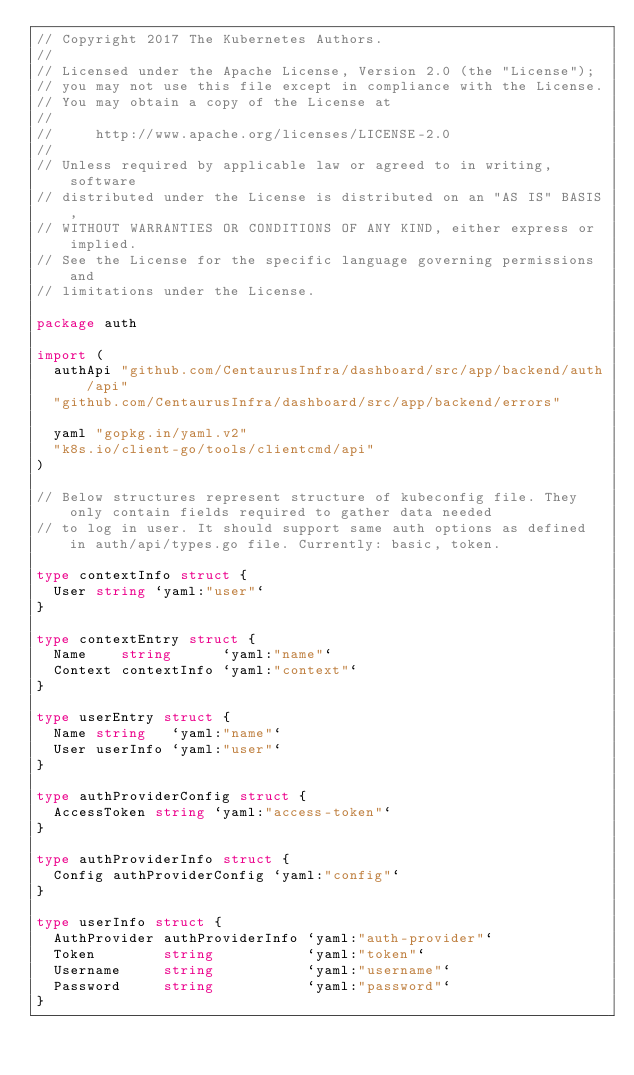<code> <loc_0><loc_0><loc_500><loc_500><_Go_>// Copyright 2017 The Kubernetes Authors.
//
// Licensed under the Apache License, Version 2.0 (the "License");
// you may not use this file except in compliance with the License.
// You may obtain a copy of the License at
//
//     http://www.apache.org/licenses/LICENSE-2.0
//
// Unless required by applicable law or agreed to in writing, software
// distributed under the License is distributed on an "AS IS" BASIS,
// WITHOUT WARRANTIES OR CONDITIONS OF ANY KIND, either express or implied.
// See the License for the specific language governing permissions and
// limitations under the License.

package auth

import (
	authApi "github.com/CentaurusInfra/dashboard/src/app/backend/auth/api"
	"github.com/CentaurusInfra/dashboard/src/app/backend/errors"

	yaml "gopkg.in/yaml.v2"
	"k8s.io/client-go/tools/clientcmd/api"
)

// Below structures represent structure of kubeconfig file. They only contain fields required to gather data needed
// to log in user. It should support same auth options as defined in auth/api/types.go file. Currently: basic, token.

type contextInfo struct {
	User string `yaml:"user"`
}

type contextEntry struct {
	Name    string      `yaml:"name"`
	Context contextInfo `yaml:"context"`
}

type userEntry struct {
	Name string   `yaml:"name"`
	User userInfo `yaml:"user"`
}

type authProviderConfig struct {
	AccessToken string `yaml:"access-token"`
}

type authProviderInfo struct {
	Config authProviderConfig `yaml:"config"`
}

type userInfo struct {
	AuthProvider authProviderInfo `yaml:"auth-provider"`
	Token        string           `yaml:"token"`
	Username     string           `yaml:"username"`
	Password     string           `yaml:"password"`
}
</code> 